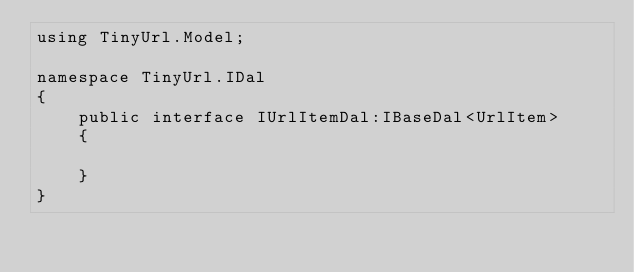<code> <loc_0><loc_0><loc_500><loc_500><_C#_>using TinyUrl.Model;

namespace TinyUrl.IDal
{
    public interface IUrlItemDal:IBaseDal<UrlItem>
    {
         
    }
}</code> 